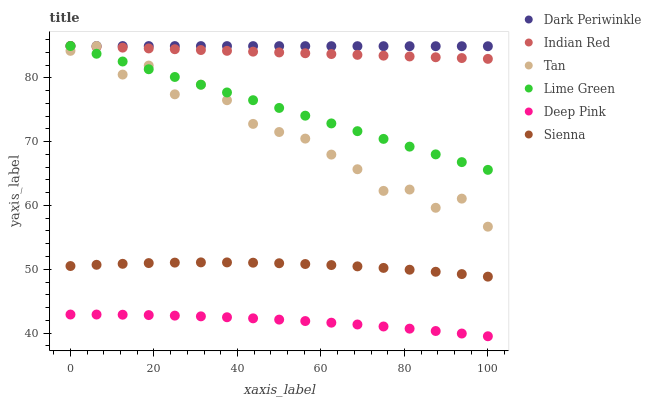Does Deep Pink have the minimum area under the curve?
Answer yes or no. Yes. Does Dark Periwinkle have the maximum area under the curve?
Answer yes or no. Yes. Does Sienna have the minimum area under the curve?
Answer yes or no. No. Does Sienna have the maximum area under the curve?
Answer yes or no. No. Is Lime Green the smoothest?
Answer yes or no. Yes. Is Tan the roughest?
Answer yes or no. Yes. Is Sienna the smoothest?
Answer yes or no. No. Is Sienna the roughest?
Answer yes or no. No. Does Deep Pink have the lowest value?
Answer yes or no. Yes. Does Sienna have the lowest value?
Answer yes or no. No. Does Dark Periwinkle have the highest value?
Answer yes or no. Yes. Does Sienna have the highest value?
Answer yes or no. No. Is Deep Pink less than Lime Green?
Answer yes or no. Yes. Is Lime Green greater than Deep Pink?
Answer yes or no. Yes. Does Lime Green intersect Indian Red?
Answer yes or no. Yes. Is Lime Green less than Indian Red?
Answer yes or no. No. Is Lime Green greater than Indian Red?
Answer yes or no. No. Does Deep Pink intersect Lime Green?
Answer yes or no. No. 